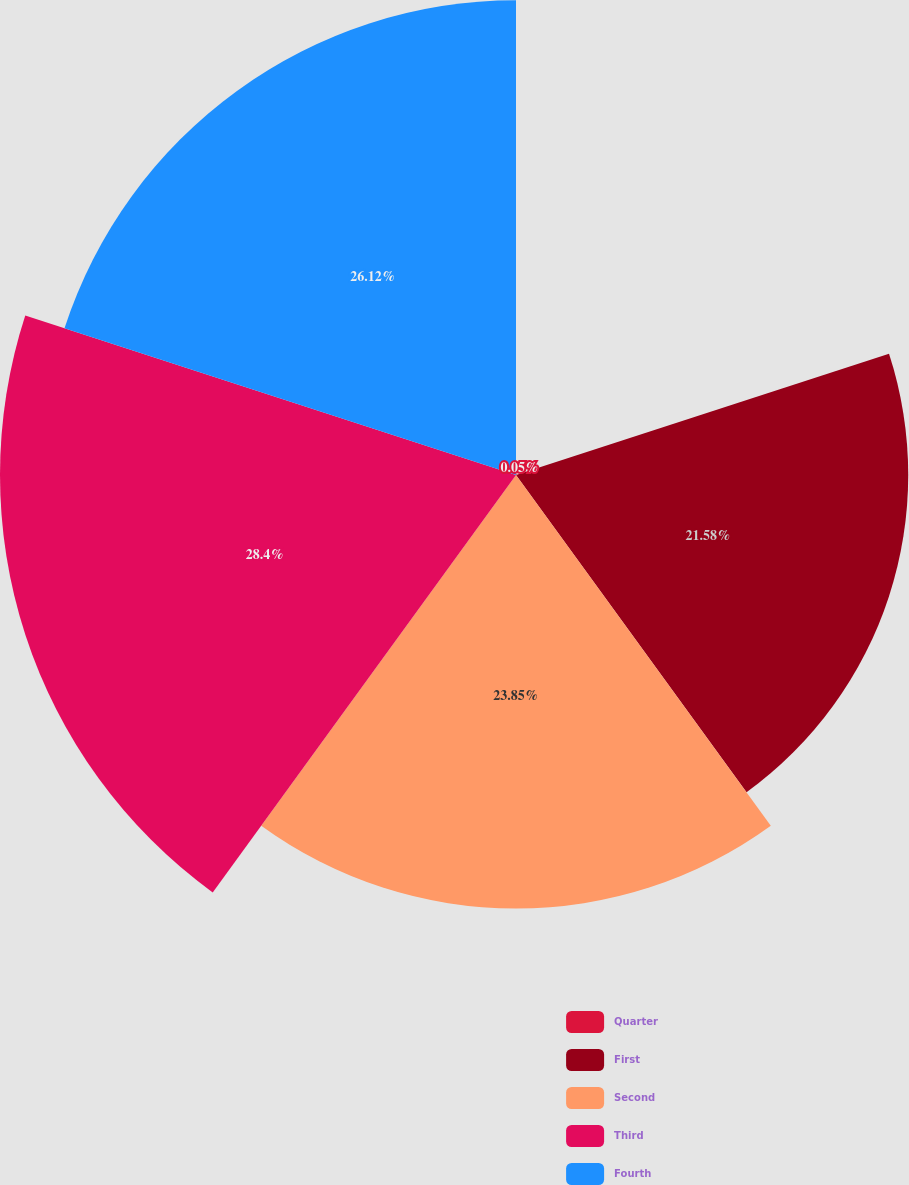Convert chart. <chart><loc_0><loc_0><loc_500><loc_500><pie_chart><fcel>Quarter<fcel>First<fcel>Second<fcel>Third<fcel>Fourth<nl><fcel>0.05%<fcel>21.58%<fcel>23.85%<fcel>28.39%<fcel>26.12%<nl></chart> 